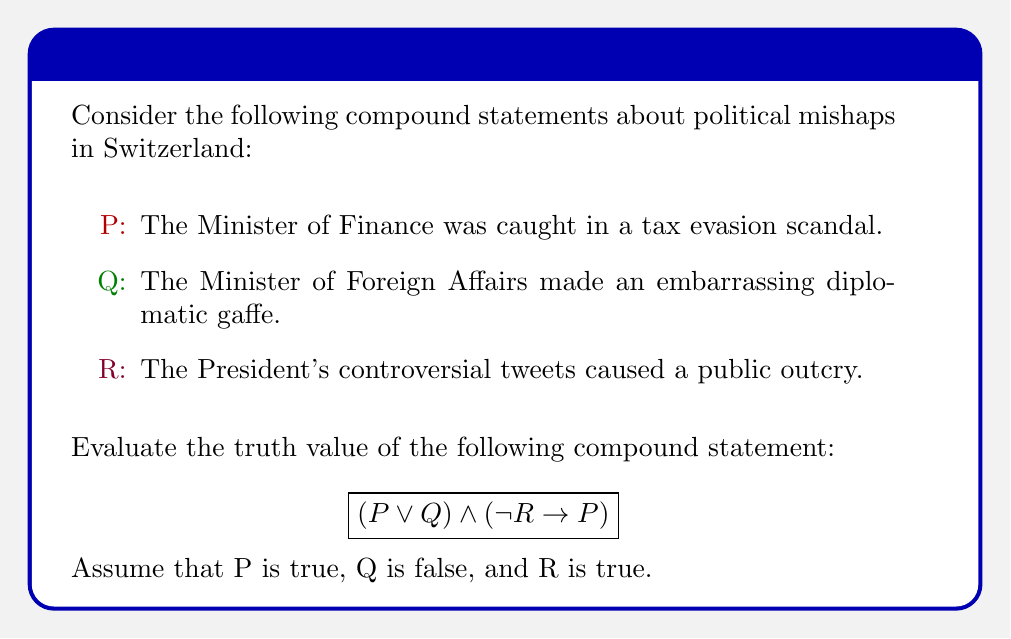Provide a solution to this math problem. Let's evaluate this compound statement step by step:

1) First, let's recall the given truth values:
   P: True
   Q: False
   R: True

2) Let's evaluate the first part: $(P \lor Q)$
   - $P \lor Q$ is true if either P or Q (or both) are true.
   - We know P is true, so $P \lor Q$ is true regardless of Q's value.
   - Therefore, $(P \lor Q)$ = True

3) Now, let's evaluate the second part: $(\lnot R \rightarrow P)$
   - First, we need to determine $\lnot R$:
     R is true, so $\lnot R$ is false.
   - Now we have: (False $\rightarrow$ True)
   - Recall that a conditional statement is only false when the antecedent is true and the consequent is false. In all other cases, including this one, it's true.
   - Therefore, $(\lnot R \rightarrow P)$ = True

4) Finally, we combine these results using $\land$:
   $(P \lor Q) \land (\lnot R \rightarrow P)$
   = True $\land$ True
   = True

Thus, the entire compound statement is true.
Answer: True 